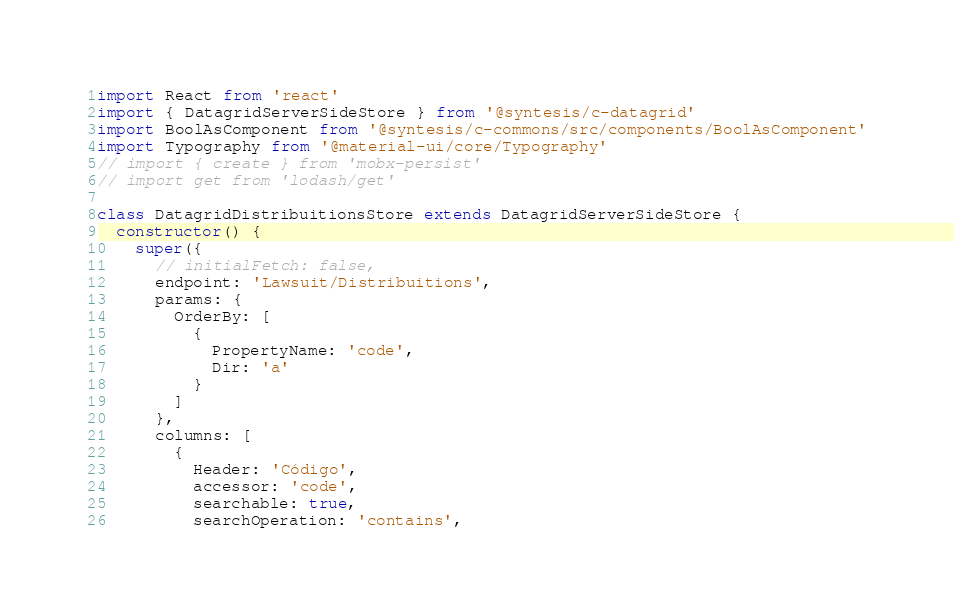Convert code to text. <code><loc_0><loc_0><loc_500><loc_500><_JavaScript_>import React from 'react'
import { DatagridServerSideStore } from '@syntesis/c-datagrid'
import BoolAsComponent from '@syntesis/c-commons/src/components/BoolAsComponent'
import Typography from '@material-ui/core/Typography'
// import { create } from 'mobx-persist'
// import get from 'lodash/get'

class DatagridDistribuitionsStore extends DatagridServerSideStore {
  constructor() {
    super({
      // initialFetch: false,
      endpoint: 'Lawsuit/Distribuitions',
      params: {
        OrderBy: [
          {
            PropertyName: 'code',
            Dir: 'a'
          }
        ]
      },
      columns: [
        {
          Header: 'Código',
          accessor: 'code',
          searchable: true,
          searchOperation: 'contains',</code> 